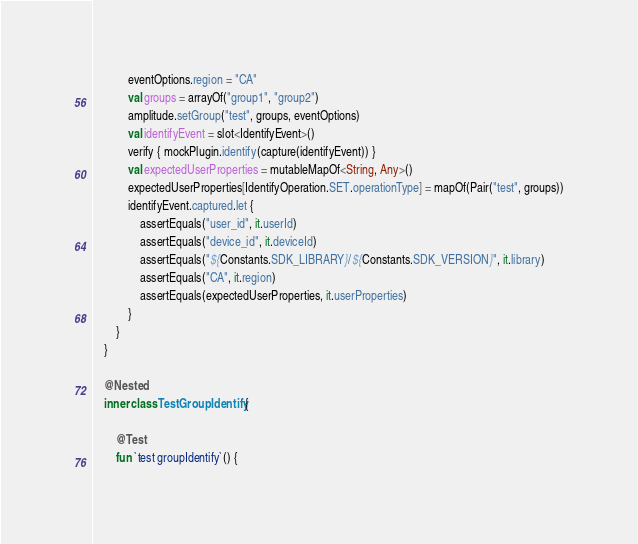Convert code to text. <code><loc_0><loc_0><loc_500><loc_500><_Kotlin_>            eventOptions.region = "CA"
            val groups = arrayOf("group1", "group2")
            amplitude.setGroup("test", groups, eventOptions)
            val identifyEvent = slot<IdentifyEvent>()
            verify { mockPlugin.identify(capture(identifyEvent)) }
            val expectedUserProperties = mutableMapOf<String, Any>()
            expectedUserProperties[IdentifyOperation.SET.operationType] = mapOf(Pair("test", groups))
            identifyEvent.captured.let {
                assertEquals("user_id", it.userId)
                assertEquals("device_id", it.deviceId)
                assertEquals("${Constants.SDK_LIBRARY}/${Constants.SDK_VERSION}", it.library)
                assertEquals("CA", it.region)
                assertEquals(expectedUserProperties, it.userProperties)
            }
        }
    }

    @Nested
    inner class TestGroupIdentify {

        @Test
        fun `test groupIdentify`() {</code> 